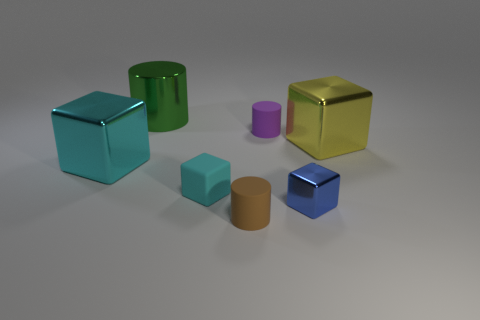Subtract all big metal cylinders. How many cylinders are left? 2 Subtract all yellow blocks. How many blocks are left? 3 Subtract 1 cylinders. How many cylinders are left? 2 Subtract all blocks. How many objects are left? 3 Subtract all cyan cylinders. How many gray cubes are left? 0 Subtract all big objects. Subtract all tiny cubes. How many objects are left? 2 Add 7 blue blocks. How many blue blocks are left? 8 Add 6 tiny green things. How many tiny green things exist? 6 Add 1 green shiny objects. How many objects exist? 8 Subtract 0 purple cubes. How many objects are left? 7 